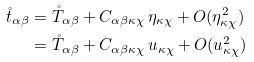Convert formula to latex. <formula><loc_0><loc_0><loc_500><loc_500>\mathring { t } _ { \alpha \beta } & = \mathring { T } _ { \alpha \beta } + C _ { \alpha \beta \kappa \chi } \, \eta _ { \kappa \chi } + O ( \eta _ { \kappa \chi } ^ { 2 } ) \\ & = \mathring { T } _ { \alpha \beta } + C _ { \alpha \beta \kappa \chi } \, u _ { \kappa \chi } + O ( u _ { \kappa \chi } ^ { 2 } )</formula> 